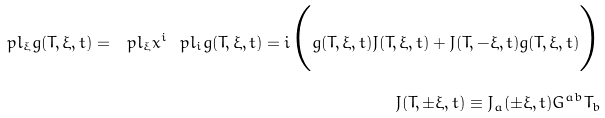Convert formula to latex. <formula><loc_0><loc_0><loc_500><loc_500>\ p l _ { \xi } g ( T , \xi , t ) = \ p l _ { \xi } x ^ { i } \ p l _ { i } g ( T , \xi , t ) = i \Big { ( } g ( T , \xi , t ) J ( T , \xi , t ) + J ( T , - \xi , t ) g ( T , \xi , t ) \Big { ) } \\ J ( T , \pm \xi , t ) \equiv J _ { a } ( \pm \xi , t ) G ^ { a b } T _ { b }</formula> 